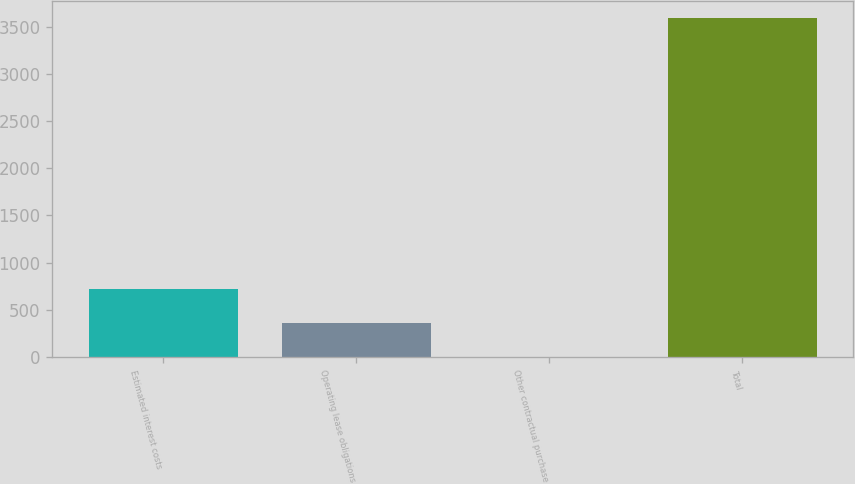<chart> <loc_0><loc_0><loc_500><loc_500><bar_chart><fcel>Estimated interest costs<fcel>Operating lease obligations<fcel>Other contractual purchase<fcel>Total<nl><fcel>722.8<fcel>363.4<fcel>4<fcel>3598<nl></chart> 